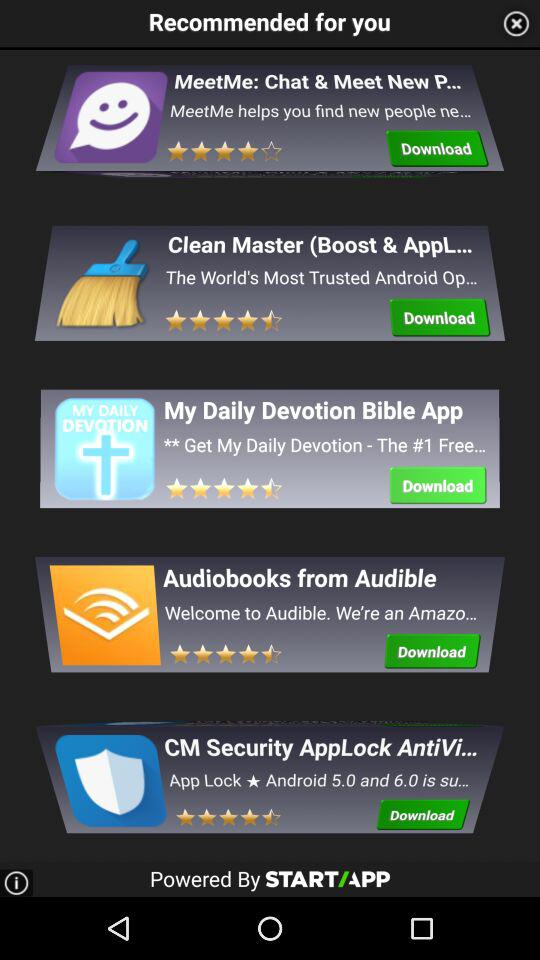What are the ratings of "MeetMe: Chat & Meet New P..."? The rating is 4 stars. 